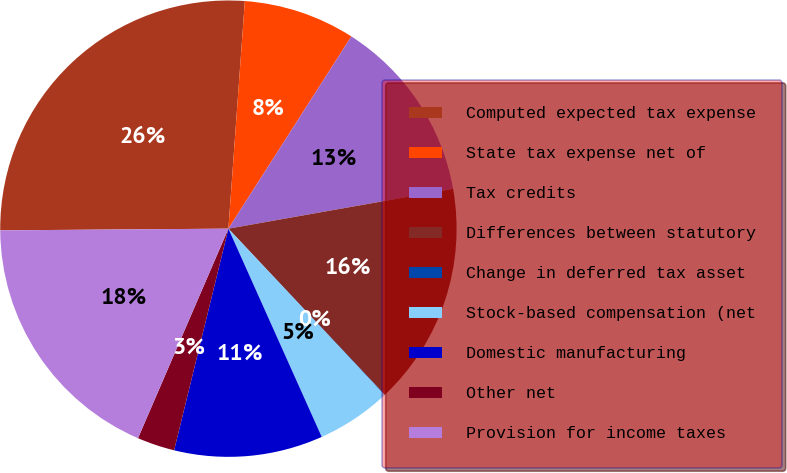Convert chart to OTSL. <chart><loc_0><loc_0><loc_500><loc_500><pie_chart><fcel>Computed expected tax expense<fcel>State tax expense net of<fcel>Tax credits<fcel>Differences between statutory<fcel>Change in deferred tax asset<fcel>Stock-based compensation (net<fcel>Domestic manufacturing<fcel>Other net<fcel>Provision for income taxes<nl><fcel>26.27%<fcel>7.91%<fcel>13.15%<fcel>15.77%<fcel>0.04%<fcel>5.28%<fcel>10.53%<fcel>2.66%<fcel>18.4%<nl></chart> 